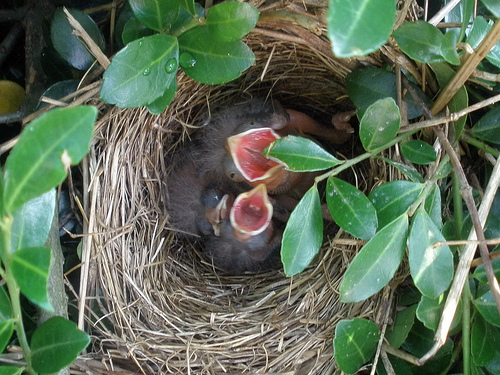Can you tell me what species of bird these chicks might be? Without more specific visual identifiers, it's difficult to determine the exact species of these chicks. However, they appear to be songbirds, which is a broad category of birds known for their musical calls. 